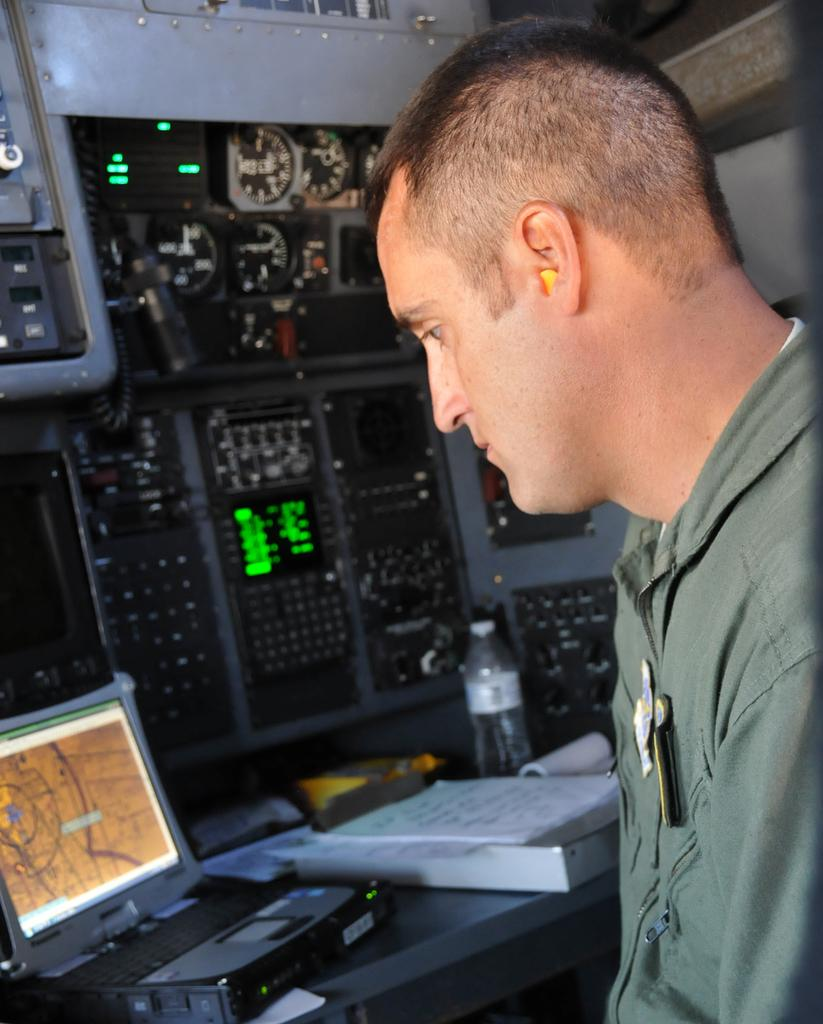Who is present in the image? There is a person in the image. What is the person wearing? The person is wearing a green shirt. What can be seen in the background of the image? There is a laptop, books, and machines in the background of the image. How many cows are visible in the image? There are no cows present in the image. What type of nut is being used to power the machines in the image? There is no mention of nuts being used to power the machines in the image. 